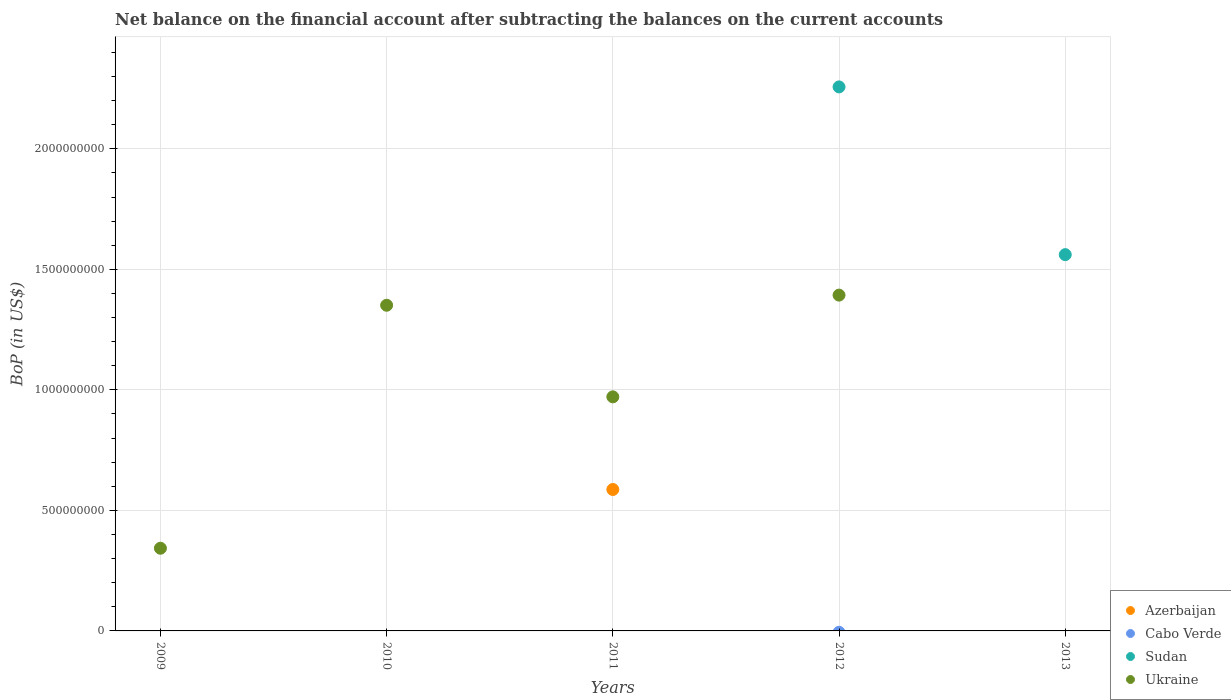How many different coloured dotlines are there?
Your answer should be very brief. 3. Across all years, what is the maximum Balance of Payments in Sudan?
Ensure brevity in your answer.  2.26e+09. Across all years, what is the minimum Balance of Payments in Azerbaijan?
Provide a short and direct response. 0. What is the total Balance of Payments in Cabo Verde in the graph?
Your response must be concise. 0. What is the difference between the Balance of Payments in Ukraine in 2011 and that in 2012?
Make the answer very short. -4.22e+08. What is the difference between the Balance of Payments in Azerbaijan in 2013 and the Balance of Payments in Ukraine in 2010?
Ensure brevity in your answer.  -1.35e+09. What is the average Balance of Payments in Azerbaijan per year?
Your answer should be compact. 1.17e+08. In the year 2011, what is the difference between the Balance of Payments in Ukraine and Balance of Payments in Azerbaijan?
Your answer should be compact. 3.84e+08. In how many years, is the Balance of Payments in Ukraine greater than 700000000 US$?
Give a very brief answer. 3. What is the ratio of the Balance of Payments in Ukraine in 2009 to that in 2010?
Ensure brevity in your answer.  0.25. What is the difference between the highest and the second highest Balance of Payments in Ukraine?
Offer a terse response. 4.20e+07. What is the difference between the highest and the lowest Balance of Payments in Sudan?
Give a very brief answer. 2.26e+09. In how many years, is the Balance of Payments in Cabo Verde greater than the average Balance of Payments in Cabo Verde taken over all years?
Keep it short and to the point. 0. Is it the case that in every year, the sum of the Balance of Payments in Azerbaijan and Balance of Payments in Cabo Verde  is greater than the sum of Balance of Payments in Ukraine and Balance of Payments in Sudan?
Offer a very short reply. No. Is it the case that in every year, the sum of the Balance of Payments in Ukraine and Balance of Payments in Azerbaijan  is greater than the Balance of Payments in Cabo Verde?
Give a very brief answer. No. Does the Balance of Payments in Sudan monotonically increase over the years?
Offer a very short reply. No. How many years are there in the graph?
Make the answer very short. 5. What is the difference between two consecutive major ticks on the Y-axis?
Ensure brevity in your answer.  5.00e+08. Are the values on the major ticks of Y-axis written in scientific E-notation?
Your answer should be very brief. No. Does the graph contain grids?
Give a very brief answer. Yes. What is the title of the graph?
Make the answer very short. Net balance on the financial account after subtracting the balances on the current accounts. Does "Kazakhstan" appear as one of the legend labels in the graph?
Keep it short and to the point. No. What is the label or title of the Y-axis?
Make the answer very short. BoP (in US$). What is the BoP (in US$) of Azerbaijan in 2009?
Your answer should be compact. 0. What is the BoP (in US$) of Ukraine in 2009?
Keep it short and to the point. 3.43e+08. What is the BoP (in US$) of Azerbaijan in 2010?
Provide a short and direct response. 0. What is the BoP (in US$) in Ukraine in 2010?
Your answer should be very brief. 1.35e+09. What is the BoP (in US$) of Azerbaijan in 2011?
Your answer should be very brief. 5.87e+08. What is the BoP (in US$) of Cabo Verde in 2011?
Your answer should be very brief. 0. What is the BoP (in US$) of Sudan in 2011?
Offer a terse response. 0. What is the BoP (in US$) of Ukraine in 2011?
Make the answer very short. 9.71e+08. What is the BoP (in US$) of Sudan in 2012?
Give a very brief answer. 2.26e+09. What is the BoP (in US$) in Ukraine in 2012?
Offer a terse response. 1.39e+09. What is the BoP (in US$) in Sudan in 2013?
Provide a short and direct response. 1.56e+09. What is the BoP (in US$) of Ukraine in 2013?
Offer a terse response. 0. Across all years, what is the maximum BoP (in US$) in Azerbaijan?
Offer a very short reply. 5.87e+08. Across all years, what is the maximum BoP (in US$) of Sudan?
Your answer should be compact. 2.26e+09. Across all years, what is the maximum BoP (in US$) of Ukraine?
Offer a very short reply. 1.39e+09. Across all years, what is the minimum BoP (in US$) of Azerbaijan?
Provide a succinct answer. 0. Across all years, what is the minimum BoP (in US$) of Sudan?
Offer a terse response. 0. What is the total BoP (in US$) of Azerbaijan in the graph?
Your answer should be compact. 5.87e+08. What is the total BoP (in US$) in Cabo Verde in the graph?
Provide a succinct answer. 0. What is the total BoP (in US$) of Sudan in the graph?
Your answer should be compact. 3.82e+09. What is the total BoP (in US$) of Ukraine in the graph?
Make the answer very short. 4.06e+09. What is the difference between the BoP (in US$) in Ukraine in 2009 and that in 2010?
Provide a short and direct response. -1.01e+09. What is the difference between the BoP (in US$) of Ukraine in 2009 and that in 2011?
Ensure brevity in your answer.  -6.28e+08. What is the difference between the BoP (in US$) of Ukraine in 2009 and that in 2012?
Provide a short and direct response. -1.05e+09. What is the difference between the BoP (in US$) in Ukraine in 2010 and that in 2011?
Keep it short and to the point. 3.80e+08. What is the difference between the BoP (in US$) of Ukraine in 2010 and that in 2012?
Provide a short and direct response. -4.20e+07. What is the difference between the BoP (in US$) in Ukraine in 2011 and that in 2012?
Your response must be concise. -4.22e+08. What is the difference between the BoP (in US$) in Sudan in 2012 and that in 2013?
Provide a succinct answer. 6.96e+08. What is the difference between the BoP (in US$) in Azerbaijan in 2011 and the BoP (in US$) in Sudan in 2012?
Offer a very short reply. -1.67e+09. What is the difference between the BoP (in US$) of Azerbaijan in 2011 and the BoP (in US$) of Ukraine in 2012?
Make the answer very short. -8.06e+08. What is the difference between the BoP (in US$) in Azerbaijan in 2011 and the BoP (in US$) in Sudan in 2013?
Your answer should be very brief. -9.74e+08. What is the average BoP (in US$) of Azerbaijan per year?
Give a very brief answer. 1.17e+08. What is the average BoP (in US$) in Cabo Verde per year?
Offer a terse response. 0. What is the average BoP (in US$) in Sudan per year?
Give a very brief answer. 7.64e+08. What is the average BoP (in US$) in Ukraine per year?
Provide a succinct answer. 8.12e+08. In the year 2011, what is the difference between the BoP (in US$) of Azerbaijan and BoP (in US$) of Ukraine?
Make the answer very short. -3.84e+08. In the year 2012, what is the difference between the BoP (in US$) of Sudan and BoP (in US$) of Ukraine?
Offer a terse response. 8.64e+08. What is the ratio of the BoP (in US$) of Ukraine in 2009 to that in 2010?
Offer a terse response. 0.25. What is the ratio of the BoP (in US$) in Ukraine in 2009 to that in 2011?
Provide a short and direct response. 0.35. What is the ratio of the BoP (in US$) of Ukraine in 2009 to that in 2012?
Offer a terse response. 0.25. What is the ratio of the BoP (in US$) of Ukraine in 2010 to that in 2011?
Offer a very short reply. 1.39. What is the ratio of the BoP (in US$) of Ukraine in 2010 to that in 2012?
Offer a very short reply. 0.97. What is the ratio of the BoP (in US$) of Ukraine in 2011 to that in 2012?
Make the answer very short. 0.7. What is the ratio of the BoP (in US$) in Sudan in 2012 to that in 2013?
Offer a terse response. 1.45. What is the difference between the highest and the second highest BoP (in US$) in Ukraine?
Offer a very short reply. 4.20e+07. What is the difference between the highest and the lowest BoP (in US$) of Azerbaijan?
Ensure brevity in your answer.  5.87e+08. What is the difference between the highest and the lowest BoP (in US$) in Sudan?
Your answer should be very brief. 2.26e+09. What is the difference between the highest and the lowest BoP (in US$) in Ukraine?
Your response must be concise. 1.39e+09. 